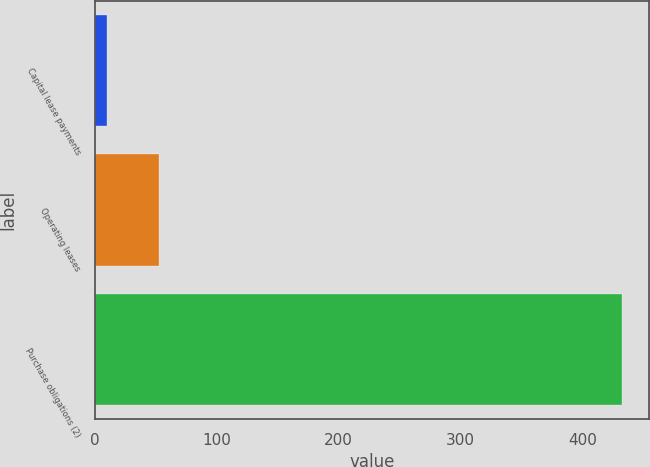Convert chart. <chart><loc_0><loc_0><loc_500><loc_500><bar_chart><fcel>Capital lease payments<fcel>Operating leases<fcel>Purchase obligations (2)<nl><fcel>10<fcel>52.3<fcel>433<nl></chart> 